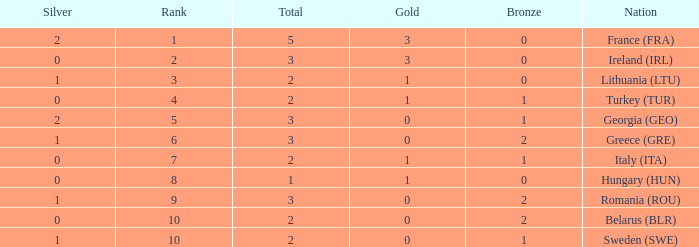What are the most bronze medals in a rank more than 1 with a total larger than 3? None. 